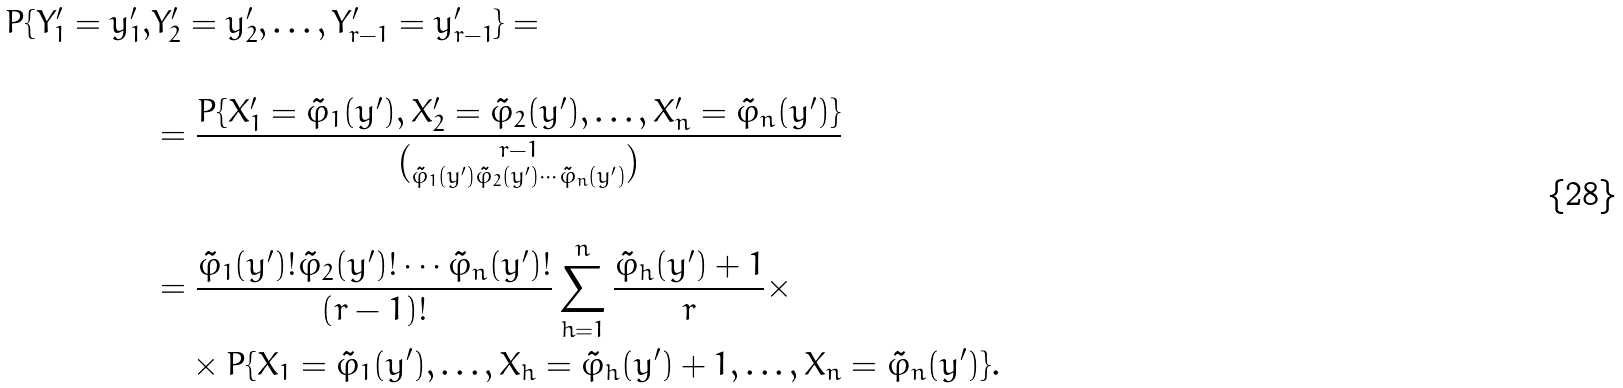<formula> <loc_0><loc_0><loc_500><loc_500>P \{ Y _ { 1 } ^ { \prime } = y _ { 1 } ^ { \prime } , & Y _ { 2 } ^ { \prime } = y _ { 2 } ^ { \prime } , \dots , Y _ { r - 1 } ^ { \prime } = y _ { r - 1 } ^ { \prime } \} = \\ & \\ & = \frac { P \{ X _ { 1 } ^ { \prime } = \tilde { \varphi } _ { 1 } ( y ^ { \prime } ) , X _ { 2 } ^ { \prime } = \tilde { \varphi } _ { 2 } ( y ^ { \prime } ) , \dots , X _ { n } ^ { \prime } = \tilde { \varphi } _ { n } ( y ^ { \prime } ) \} } { \binom { r - 1 } { \tilde { \varphi } _ { 1 } ( y ^ { \prime } ) \tilde { \varphi } _ { 2 } ( y ^ { \prime } ) \cdots \tilde { \varphi } _ { n } ( y ^ { \prime } ) } } \\ & \\ & = \frac { \tilde { \varphi } _ { 1 } ( y ^ { \prime } ) ! \tilde { \varphi } _ { 2 } ( y ^ { \prime } ) ! \cdots \tilde { \varphi } _ { n } ( y ^ { \prime } ) ! } { ( r - 1 ) ! } \sum _ { h = 1 } ^ { n } \frac { \tilde { \varphi } _ { h } ( y ^ { \prime } ) + 1 } { r } \times \\ & \quad \times P \{ X _ { 1 } = \tilde { \varphi } _ { 1 } ( y ^ { \prime } ) , \dots , X _ { h } = \tilde { \varphi } _ { h } ( y ^ { \prime } ) + 1 , \dots , X _ { n } = \tilde { \varphi } _ { n } ( y ^ { \prime } ) \} .</formula> 